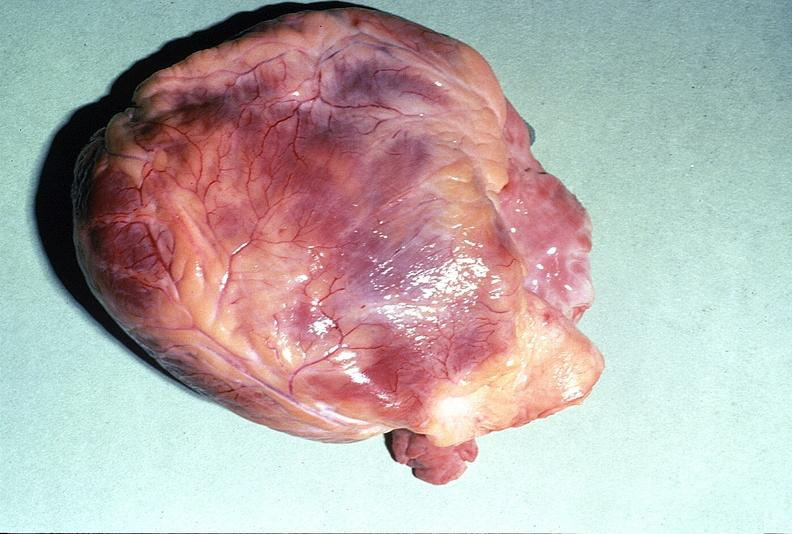does atrophy show normal cardiovascular?
Answer the question using a single word or phrase. No 